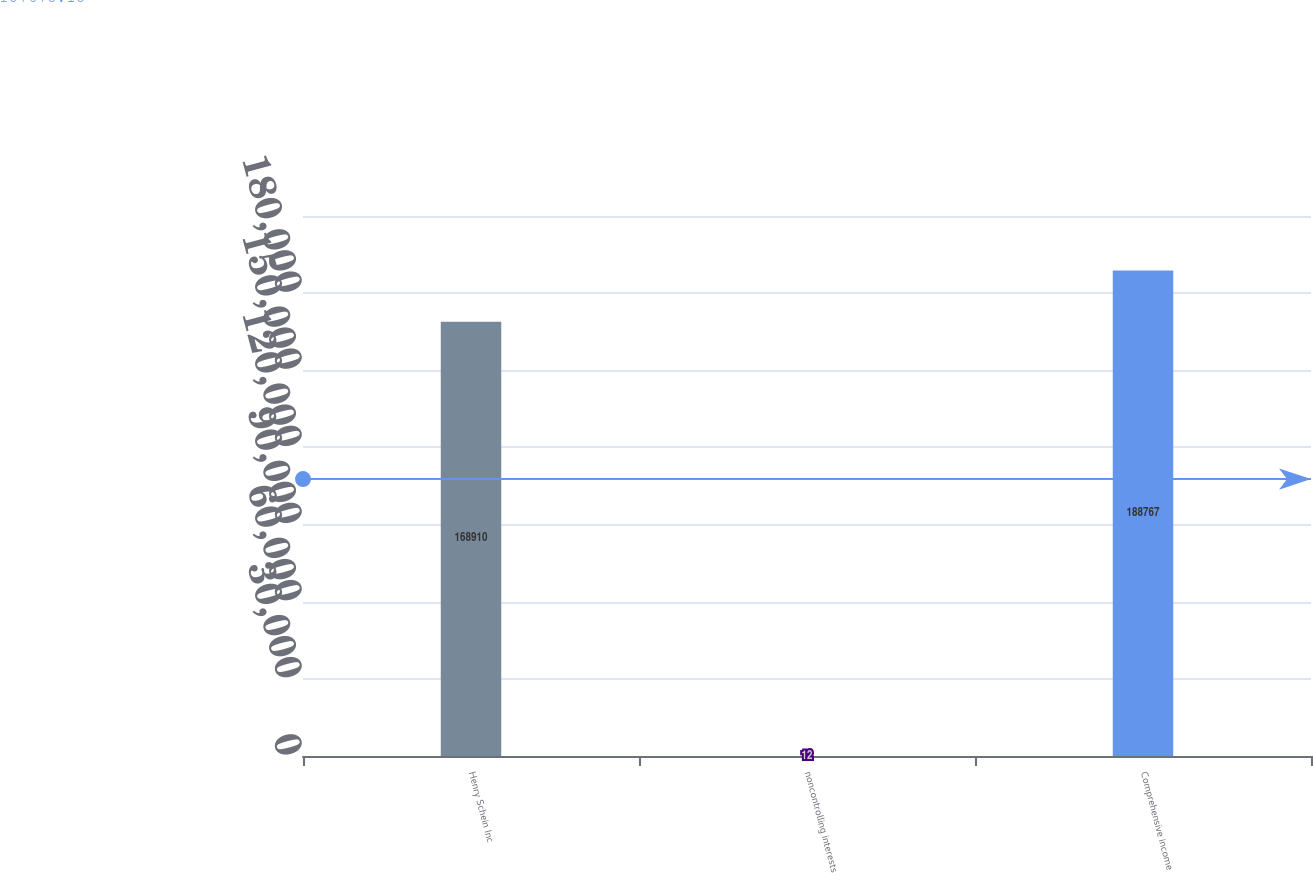<chart> <loc_0><loc_0><loc_500><loc_500><bar_chart><fcel>Henry Schein Inc<fcel>noncontrolling interests<fcel>Comprehensive income<nl><fcel>168910<fcel>12<fcel>188767<nl></chart> 